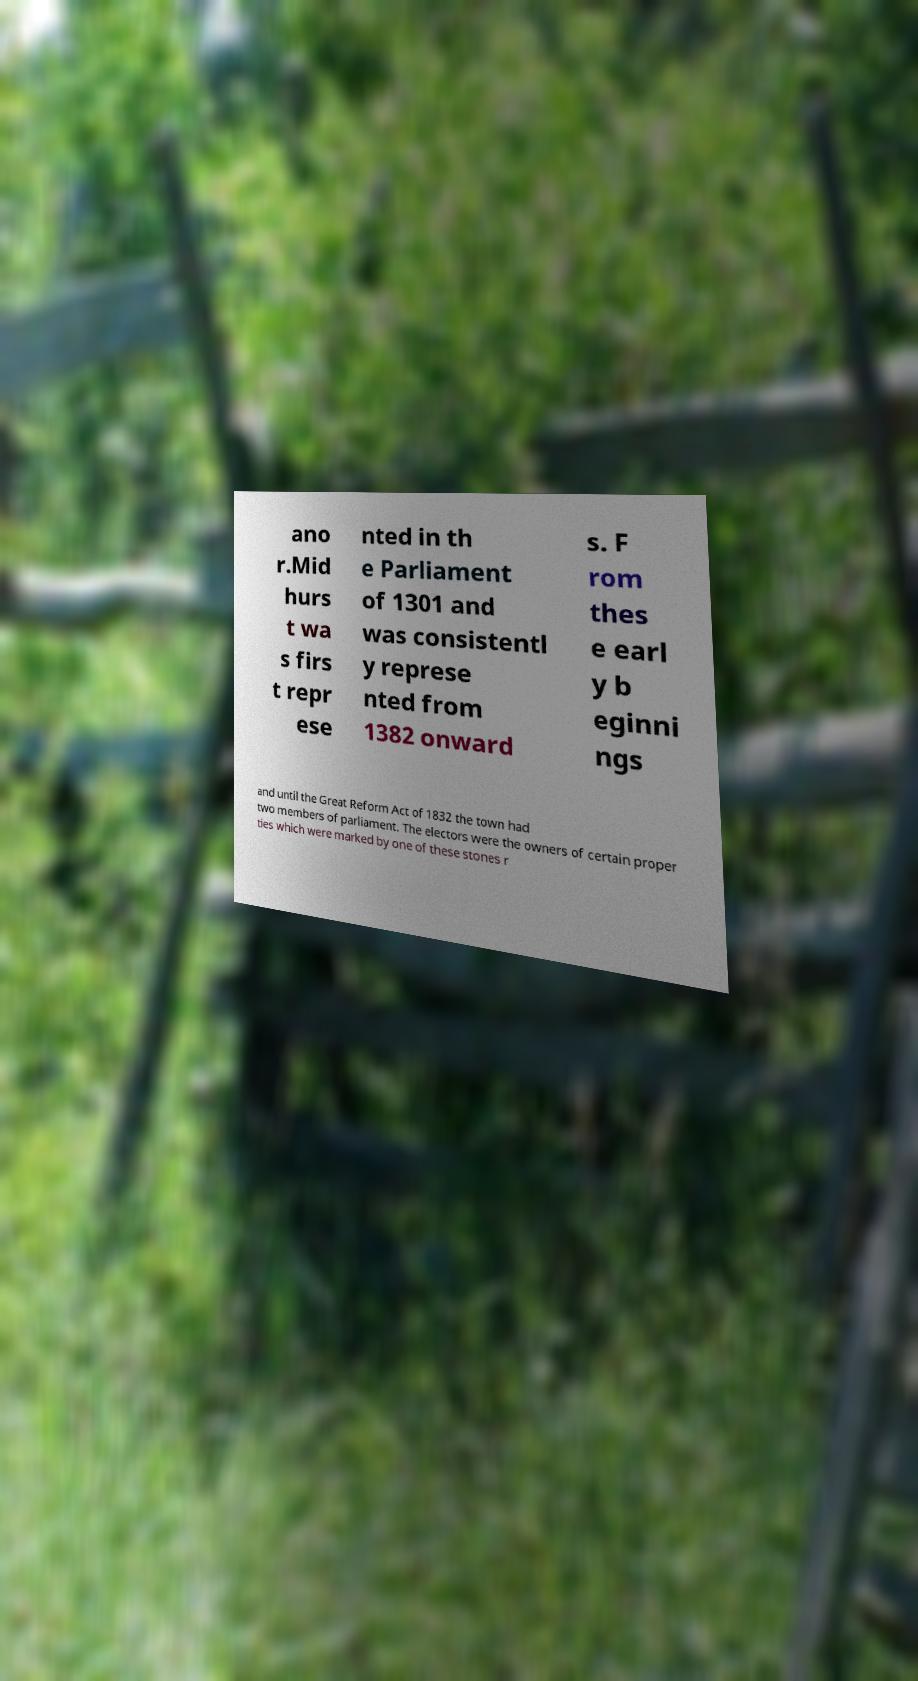I need the written content from this picture converted into text. Can you do that? ano r.Mid hurs t wa s firs t repr ese nted in th e Parliament of 1301 and was consistentl y represe nted from 1382 onward s. F rom thes e earl y b eginni ngs and until the Great Reform Act of 1832 the town had two members of parliament. The electors were the owners of certain proper ties which were marked by one of these stones r 